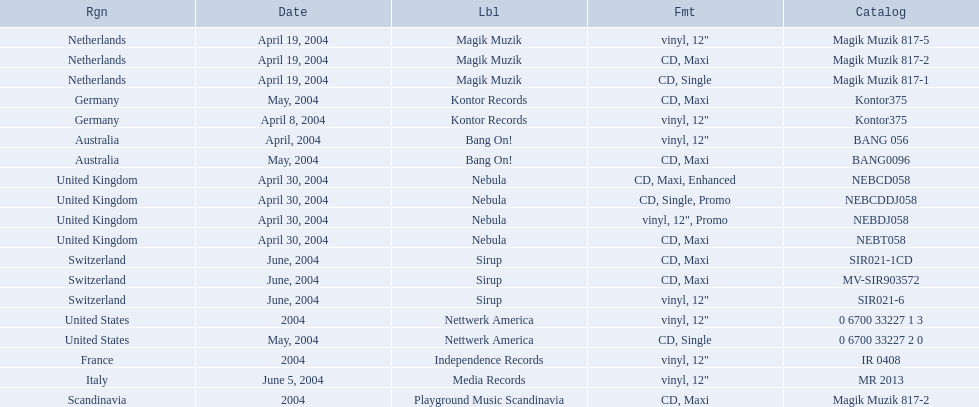What are all of the regions the title was released in? Netherlands, Netherlands, Netherlands, Germany, Germany, Australia, Australia, United Kingdom, United Kingdom, United Kingdom, United Kingdom, Switzerland, Switzerland, Switzerland, United States, United States, France, Italy, Scandinavia. And under which labels were they released? Magik Muzik, Magik Muzik, Magik Muzik, Kontor Records, Kontor Records, Bang On!, Bang On!, Nebula, Nebula, Nebula, Nebula, Sirup, Sirup, Sirup, Nettwerk America, Nettwerk America, Independence Records, Media Records, Playground Music Scandinavia. Which label released the song in france? Independence Records. 